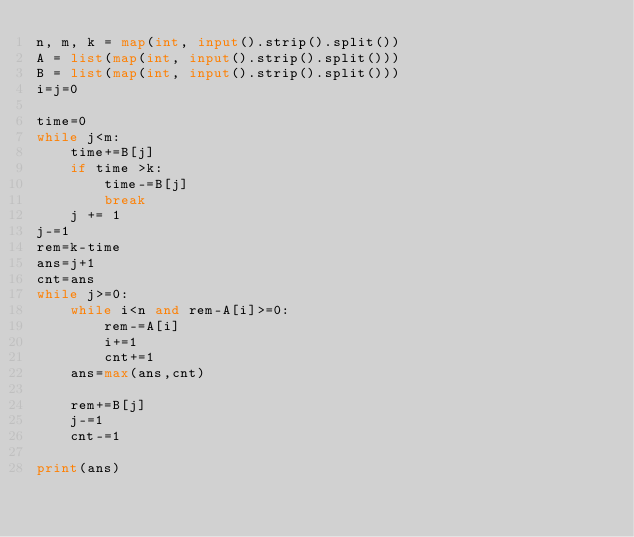Convert code to text. <code><loc_0><loc_0><loc_500><loc_500><_Python_>n, m, k = map(int, input().strip().split())
A = list(map(int, input().strip().split()))
B = list(map(int, input().strip().split()))
i=j=0

time=0
while j<m:
    time+=B[j]
    if time >k:
        time-=B[j]
        break
    j += 1
j-=1
rem=k-time
ans=j+1
cnt=ans
while j>=0:
    while i<n and rem-A[i]>=0:
        rem-=A[i]
        i+=1
        cnt+=1
    ans=max(ans,cnt)
    
    rem+=B[j]
    j-=1
    cnt-=1

print(ans)</code> 